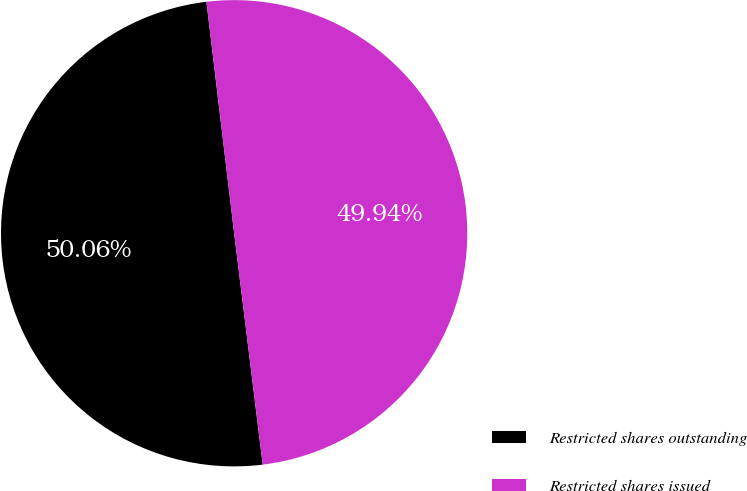Convert chart to OTSL. <chart><loc_0><loc_0><loc_500><loc_500><pie_chart><fcel>Restricted shares outstanding<fcel>Restricted shares issued<nl><fcel>50.06%<fcel>49.94%<nl></chart> 